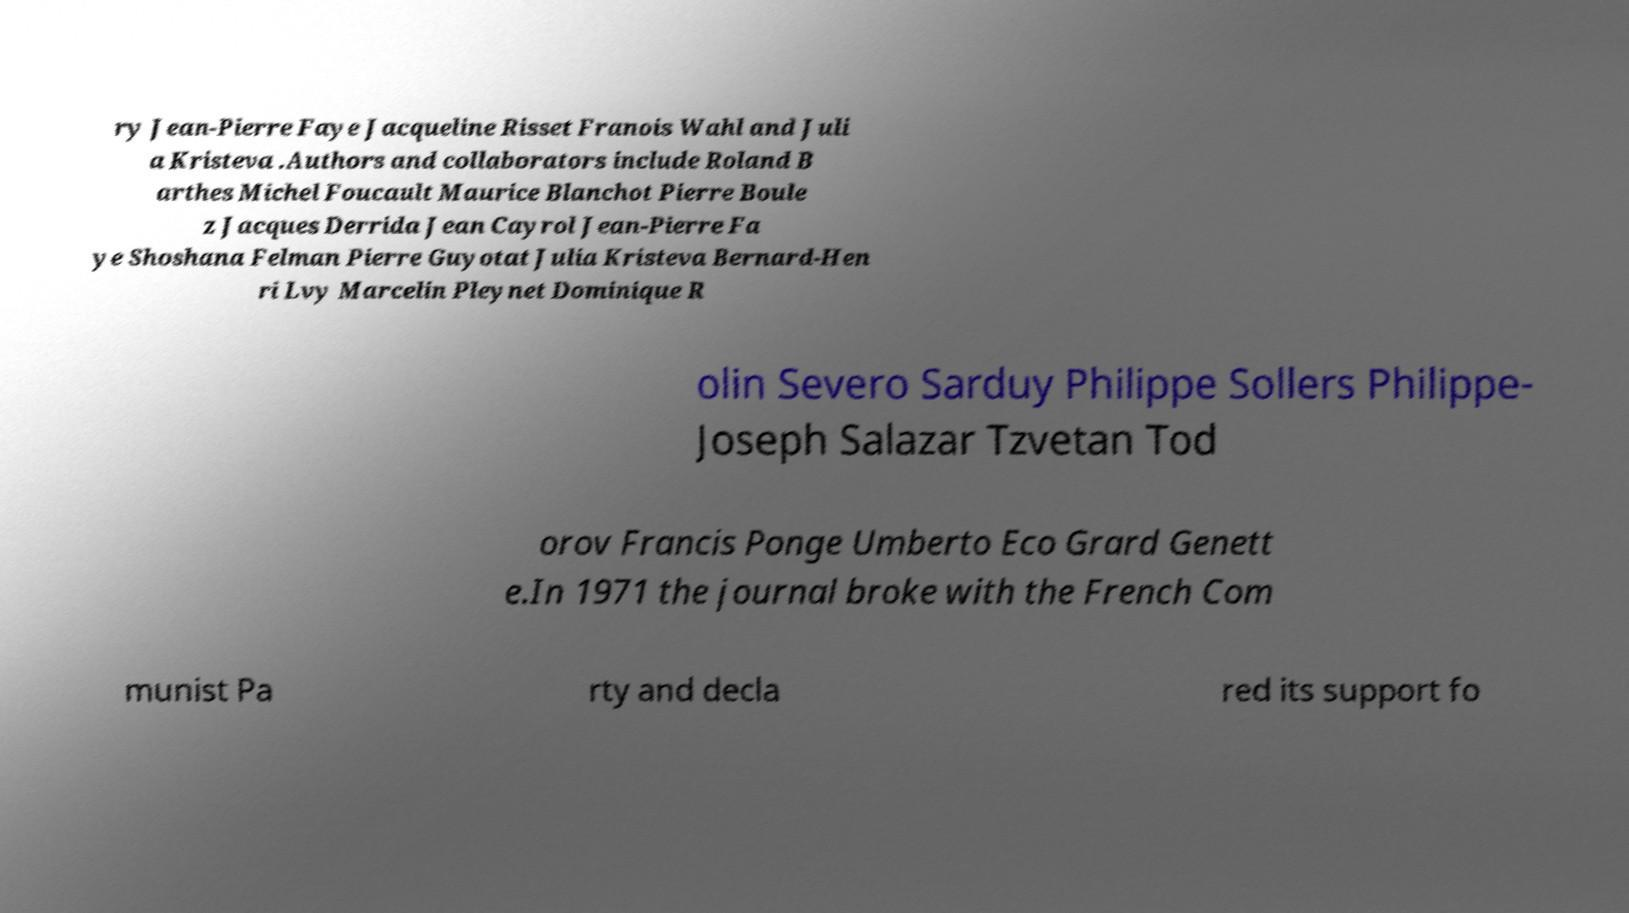Can you accurately transcribe the text from the provided image for me? ry Jean-Pierre Faye Jacqueline Risset Franois Wahl and Juli a Kristeva .Authors and collaborators include Roland B arthes Michel Foucault Maurice Blanchot Pierre Boule z Jacques Derrida Jean Cayrol Jean-Pierre Fa ye Shoshana Felman Pierre Guyotat Julia Kristeva Bernard-Hen ri Lvy Marcelin Pleynet Dominique R olin Severo Sarduy Philippe Sollers Philippe- Joseph Salazar Tzvetan Tod orov Francis Ponge Umberto Eco Grard Genett e.In 1971 the journal broke with the French Com munist Pa rty and decla red its support fo 